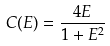Convert formula to latex. <formula><loc_0><loc_0><loc_500><loc_500>C ( E ) = \frac { 4 E } { 1 + E ^ { 2 } }</formula> 